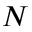<formula> <loc_0><loc_0><loc_500><loc_500>N</formula> 